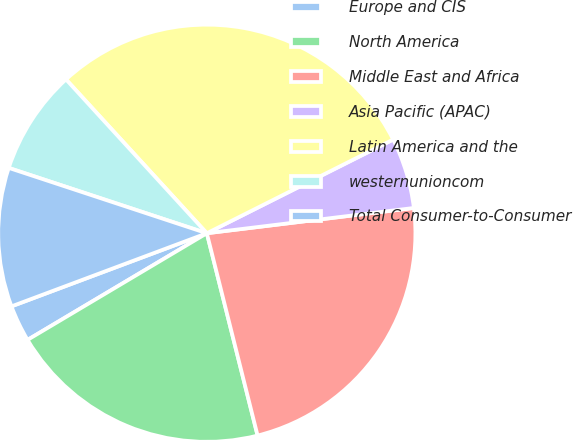Convert chart. <chart><loc_0><loc_0><loc_500><loc_500><pie_chart><fcel>Europe and CIS<fcel>North America<fcel>Middle East and Africa<fcel>Asia Pacific (APAC)<fcel>Latin America and the<fcel>westernunioncom<fcel>Total Consumer-to-Consumer<nl><fcel>2.84%<fcel>20.37%<fcel>23.02%<fcel>5.48%<fcel>29.38%<fcel>8.13%<fcel>10.77%<nl></chart> 